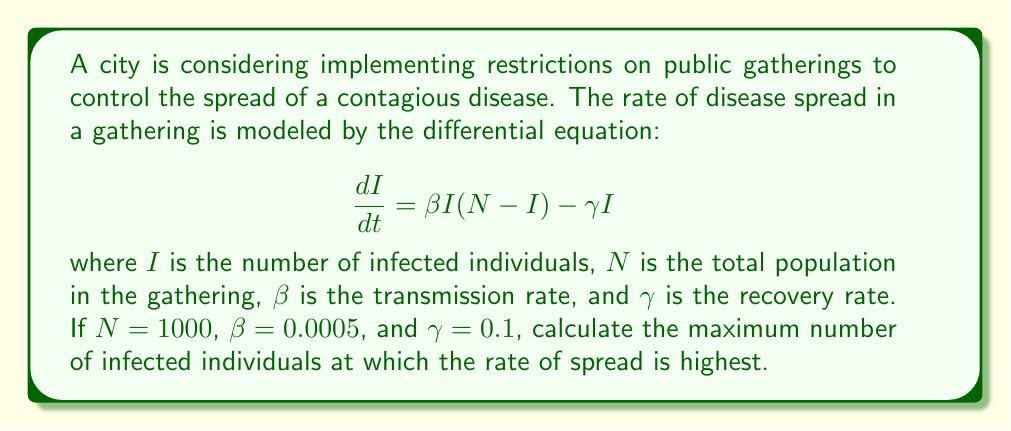Give your solution to this math problem. To find the maximum number of infected individuals at which the rate of spread is highest, we need to find the value of $I$ that maximizes $\frac{dI}{dt}$. Let's approach this step-by-step:

1) First, let's expand the equation:
   $$\frac{dI}{dt} = \beta NI - \beta I^2 - \gamma I$$

2) To find the maximum, we need to differentiate $\frac{dI}{dt}$ with respect to $I$ and set it to zero:
   $$\frac{d}{dI}\left(\frac{dI}{dt}\right) = \beta N - 2\beta I - \gamma = 0$$

3) Solve this equation for $I$:
   $$\beta N - 2\beta I - \gamma = 0$$
   $$2\beta I = \beta N - \gamma$$
   $$I = \frac{\beta N - \gamma}{2\beta}$$

4) Now, let's substitute the given values:
   $$I = \frac{0.0005 \cdot 1000 - 0.1}{2 \cdot 0.0005}$$
   $$I = \frac{0.5 - 0.1}{0.001} = \frac{0.4}{0.001} = 400$$

5) To confirm this is a maximum (not a minimum), we can check the second derivative:
   $$\frac{d^2}{dI^2}\left(\frac{dI}{dt}\right) = -2\beta$$
   Which is negative, confirming a maximum.

Therefore, the rate of spread is highest when there are 400 infected individuals in the gathering.
Answer: 400 infected individuals 